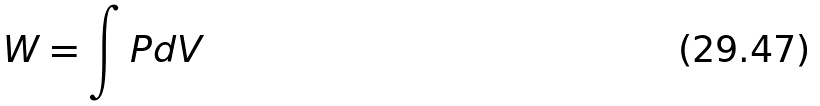<formula> <loc_0><loc_0><loc_500><loc_500>W = \int P d V</formula> 